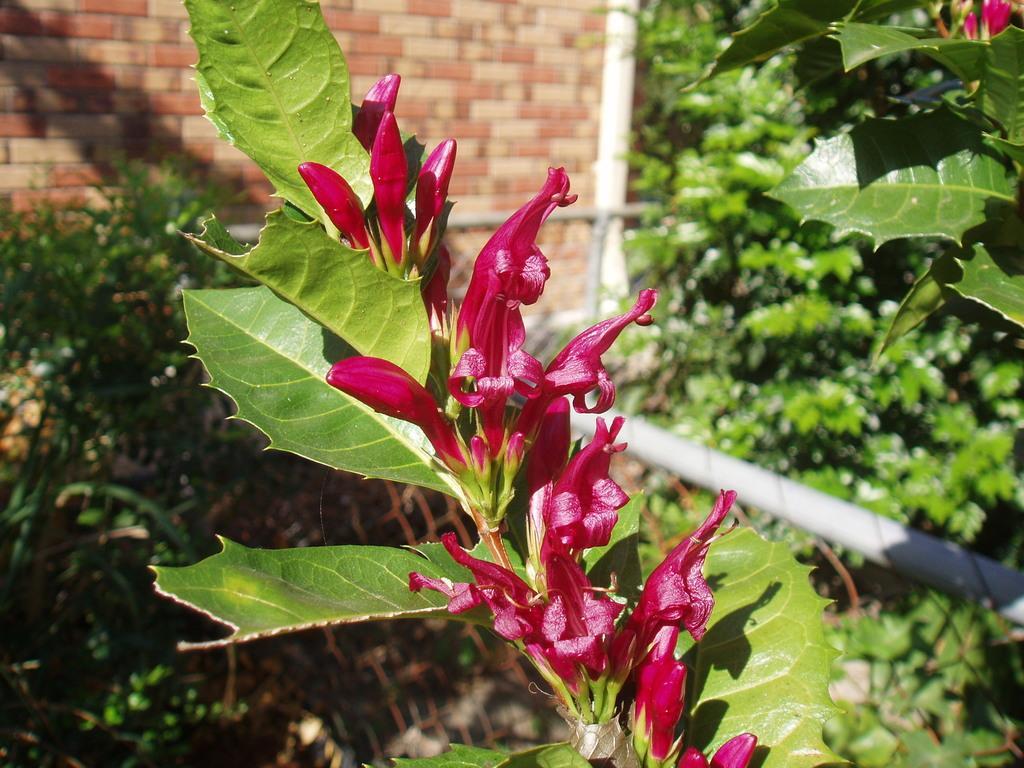Please provide a concise description of this image. In this image there are pink flowers in the middle. In the background there is a wall. On the right side there are plants. At the bottom there is a pole. 